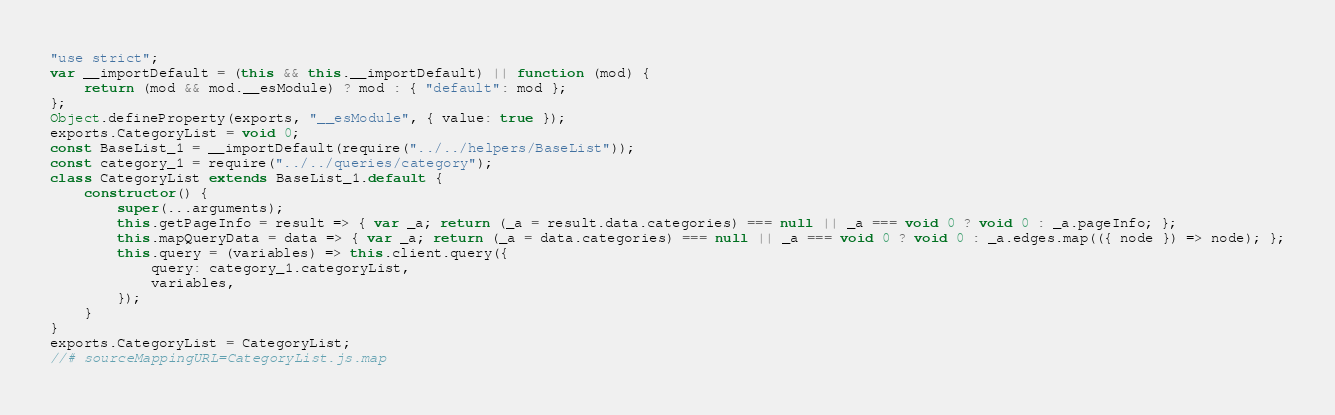Convert code to text. <code><loc_0><loc_0><loc_500><loc_500><_JavaScript_>"use strict";
var __importDefault = (this && this.__importDefault) || function (mod) {
    return (mod && mod.__esModule) ? mod : { "default": mod };
};
Object.defineProperty(exports, "__esModule", { value: true });
exports.CategoryList = void 0;
const BaseList_1 = __importDefault(require("../../helpers/BaseList"));
const category_1 = require("../../queries/category");
class CategoryList extends BaseList_1.default {
    constructor() {
        super(...arguments);
        this.getPageInfo = result => { var _a; return (_a = result.data.categories) === null || _a === void 0 ? void 0 : _a.pageInfo; };
        this.mapQueryData = data => { var _a; return (_a = data.categories) === null || _a === void 0 ? void 0 : _a.edges.map(({ node }) => node); };
        this.query = (variables) => this.client.query({
            query: category_1.categoryList,
            variables,
        });
    }
}
exports.CategoryList = CategoryList;
//# sourceMappingURL=CategoryList.js.map</code> 